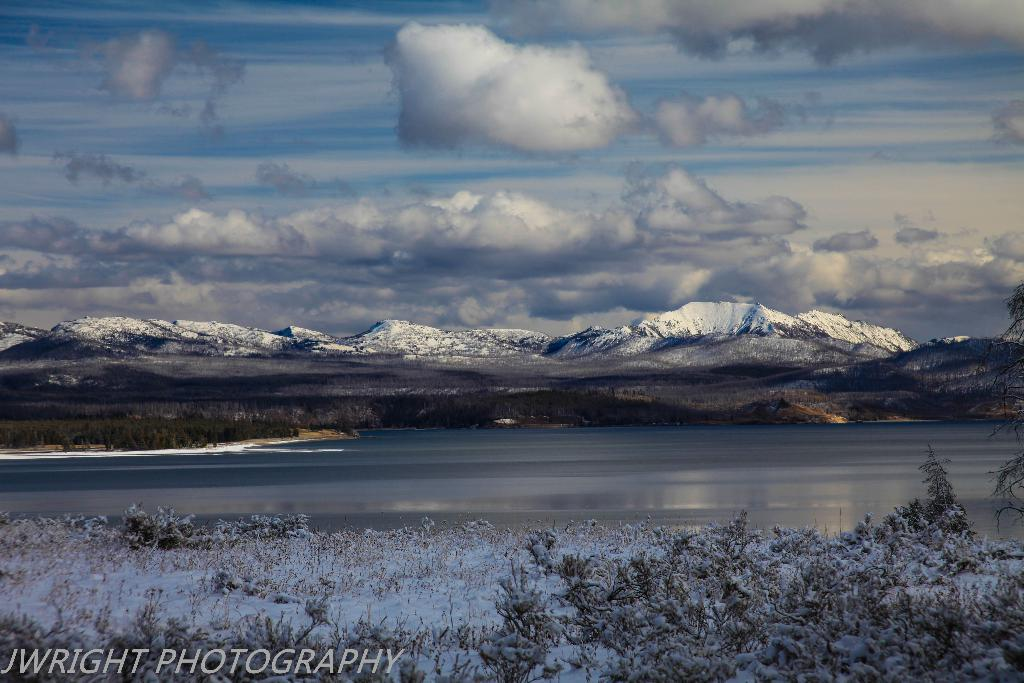What type of natural landform can be seen in the image? There are mountains in the image. What other natural elements are present in the image? There are plants, water, and ice visible in the image. What part of the sky is visible in the image? The sky is visible in the image, along with clouds. Is there any text present in the image? Yes, there is text at the bottom of the image. What type of list can be seen hanging from the clouds in the image? There is no list present in the image, nor is there anything hanging from the clouds. 